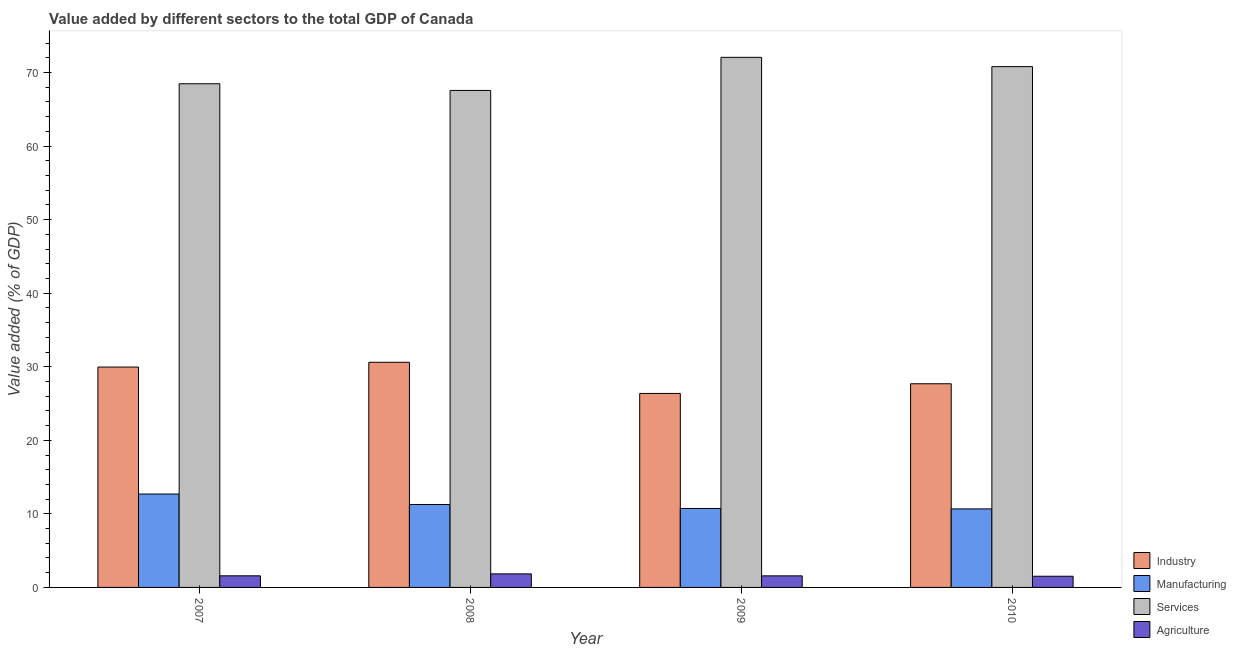How many different coloured bars are there?
Ensure brevity in your answer.  4. Are the number of bars per tick equal to the number of legend labels?
Provide a short and direct response. Yes. Are the number of bars on each tick of the X-axis equal?
Your answer should be compact. Yes. How many bars are there on the 1st tick from the left?
Provide a short and direct response. 4. How many bars are there on the 1st tick from the right?
Provide a short and direct response. 4. What is the value added by agricultural sector in 2010?
Your answer should be compact. 1.52. Across all years, what is the maximum value added by services sector?
Give a very brief answer. 72.06. Across all years, what is the minimum value added by industrial sector?
Offer a very short reply. 26.37. In which year was the value added by manufacturing sector minimum?
Keep it short and to the point. 2010. What is the total value added by services sector in the graph?
Keep it short and to the point. 278.87. What is the difference between the value added by services sector in 2008 and that in 2009?
Your answer should be very brief. -4.5. What is the difference between the value added by services sector in 2008 and the value added by agricultural sector in 2007?
Offer a very short reply. -0.91. What is the average value added by industrial sector per year?
Provide a short and direct response. 28.65. What is the ratio of the value added by manufacturing sector in 2007 to that in 2010?
Keep it short and to the point. 1.19. Is the difference between the value added by services sector in 2008 and 2010 greater than the difference between the value added by manufacturing sector in 2008 and 2010?
Keep it short and to the point. No. What is the difference between the highest and the second highest value added by services sector?
Ensure brevity in your answer.  1.26. What is the difference between the highest and the lowest value added by industrial sector?
Your answer should be very brief. 4.23. Is the sum of the value added by industrial sector in 2007 and 2009 greater than the maximum value added by agricultural sector across all years?
Provide a succinct answer. Yes. Is it the case that in every year, the sum of the value added by services sector and value added by industrial sector is greater than the sum of value added by agricultural sector and value added by manufacturing sector?
Keep it short and to the point. No. What does the 4th bar from the left in 2009 represents?
Offer a terse response. Agriculture. What does the 4th bar from the right in 2009 represents?
Your answer should be very brief. Industry. How many years are there in the graph?
Give a very brief answer. 4. What is the difference between two consecutive major ticks on the Y-axis?
Make the answer very short. 10. Are the values on the major ticks of Y-axis written in scientific E-notation?
Your answer should be compact. No. Does the graph contain any zero values?
Your response must be concise. No. Where does the legend appear in the graph?
Keep it short and to the point. Bottom right. How are the legend labels stacked?
Offer a terse response. Vertical. What is the title of the graph?
Provide a succinct answer. Value added by different sectors to the total GDP of Canada. What is the label or title of the X-axis?
Provide a short and direct response. Year. What is the label or title of the Y-axis?
Keep it short and to the point. Value added (% of GDP). What is the Value added (% of GDP) in Industry in 2007?
Your answer should be very brief. 29.95. What is the Value added (% of GDP) of Manufacturing in 2007?
Ensure brevity in your answer.  12.7. What is the Value added (% of GDP) in Services in 2007?
Provide a succinct answer. 68.47. What is the Value added (% of GDP) in Agriculture in 2007?
Your answer should be very brief. 1.58. What is the Value added (% of GDP) of Industry in 2008?
Keep it short and to the point. 30.6. What is the Value added (% of GDP) in Manufacturing in 2008?
Give a very brief answer. 11.27. What is the Value added (% of GDP) in Services in 2008?
Offer a terse response. 67.56. What is the Value added (% of GDP) of Agriculture in 2008?
Provide a succinct answer. 1.84. What is the Value added (% of GDP) in Industry in 2009?
Your answer should be compact. 26.37. What is the Value added (% of GDP) of Manufacturing in 2009?
Make the answer very short. 10.73. What is the Value added (% of GDP) in Services in 2009?
Your answer should be very brief. 72.06. What is the Value added (% of GDP) in Agriculture in 2009?
Your response must be concise. 1.57. What is the Value added (% of GDP) of Industry in 2010?
Provide a short and direct response. 27.69. What is the Value added (% of GDP) of Manufacturing in 2010?
Ensure brevity in your answer.  10.68. What is the Value added (% of GDP) of Services in 2010?
Ensure brevity in your answer.  70.79. What is the Value added (% of GDP) of Agriculture in 2010?
Make the answer very short. 1.52. Across all years, what is the maximum Value added (% of GDP) of Industry?
Provide a succinct answer. 30.6. Across all years, what is the maximum Value added (% of GDP) in Manufacturing?
Your answer should be very brief. 12.7. Across all years, what is the maximum Value added (% of GDP) of Services?
Your response must be concise. 72.06. Across all years, what is the maximum Value added (% of GDP) of Agriculture?
Provide a succinct answer. 1.84. Across all years, what is the minimum Value added (% of GDP) in Industry?
Your answer should be compact. 26.37. Across all years, what is the minimum Value added (% of GDP) of Manufacturing?
Give a very brief answer. 10.68. Across all years, what is the minimum Value added (% of GDP) in Services?
Keep it short and to the point. 67.56. Across all years, what is the minimum Value added (% of GDP) of Agriculture?
Offer a terse response. 1.52. What is the total Value added (% of GDP) of Industry in the graph?
Offer a terse response. 114.61. What is the total Value added (% of GDP) of Manufacturing in the graph?
Offer a very short reply. 45.38. What is the total Value added (% of GDP) of Services in the graph?
Provide a short and direct response. 278.87. What is the total Value added (% of GDP) in Agriculture in the graph?
Provide a short and direct response. 6.51. What is the difference between the Value added (% of GDP) of Industry in 2007 and that in 2008?
Offer a terse response. -0.65. What is the difference between the Value added (% of GDP) in Manufacturing in 2007 and that in 2008?
Ensure brevity in your answer.  1.42. What is the difference between the Value added (% of GDP) of Services in 2007 and that in 2008?
Offer a very short reply. 0.91. What is the difference between the Value added (% of GDP) of Agriculture in 2007 and that in 2008?
Provide a short and direct response. -0.26. What is the difference between the Value added (% of GDP) of Industry in 2007 and that in 2009?
Make the answer very short. 3.59. What is the difference between the Value added (% of GDP) in Manufacturing in 2007 and that in 2009?
Offer a terse response. 1.96. What is the difference between the Value added (% of GDP) of Services in 2007 and that in 2009?
Offer a terse response. -3.59. What is the difference between the Value added (% of GDP) of Agriculture in 2007 and that in 2009?
Offer a terse response. 0.01. What is the difference between the Value added (% of GDP) in Industry in 2007 and that in 2010?
Your answer should be very brief. 2.27. What is the difference between the Value added (% of GDP) in Manufacturing in 2007 and that in 2010?
Give a very brief answer. 2.02. What is the difference between the Value added (% of GDP) in Services in 2007 and that in 2010?
Give a very brief answer. -2.33. What is the difference between the Value added (% of GDP) in Agriculture in 2007 and that in 2010?
Offer a terse response. 0.06. What is the difference between the Value added (% of GDP) in Industry in 2008 and that in 2009?
Give a very brief answer. 4.23. What is the difference between the Value added (% of GDP) in Manufacturing in 2008 and that in 2009?
Provide a succinct answer. 0.54. What is the difference between the Value added (% of GDP) in Services in 2008 and that in 2009?
Provide a short and direct response. -4.5. What is the difference between the Value added (% of GDP) in Agriculture in 2008 and that in 2009?
Give a very brief answer. 0.27. What is the difference between the Value added (% of GDP) in Industry in 2008 and that in 2010?
Your answer should be very brief. 2.92. What is the difference between the Value added (% of GDP) in Manufacturing in 2008 and that in 2010?
Your response must be concise. 0.6. What is the difference between the Value added (% of GDP) in Services in 2008 and that in 2010?
Your answer should be compact. -3.24. What is the difference between the Value added (% of GDP) of Agriculture in 2008 and that in 2010?
Give a very brief answer. 0.32. What is the difference between the Value added (% of GDP) in Industry in 2009 and that in 2010?
Offer a very short reply. -1.32. What is the difference between the Value added (% of GDP) in Manufacturing in 2009 and that in 2010?
Keep it short and to the point. 0.06. What is the difference between the Value added (% of GDP) of Services in 2009 and that in 2010?
Your answer should be compact. 1.26. What is the difference between the Value added (% of GDP) in Agriculture in 2009 and that in 2010?
Offer a very short reply. 0.05. What is the difference between the Value added (% of GDP) in Industry in 2007 and the Value added (% of GDP) in Manufacturing in 2008?
Make the answer very short. 18.68. What is the difference between the Value added (% of GDP) of Industry in 2007 and the Value added (% of GDP) of Services in 2008?
Provide a succinct answer. -37.6. What is the difference between the Value added (% of GDP) of Industry in 2007 and the Value added (% of GDP) of Agriculture in 2008?
Give a very brief answer. 28.11. What is the difference between the Value added (% of GDP) in Manufacturing in 2007 and the Value added (% of GDP) in Services in 2008?
Give a very brief answer. -54.86. What is the difference between the Value added (% of GDP) in Manufacturing in 2007 and the Value added (% of GDP) in Agriculture in 2008?
Give a very brief answer. 10.85. What is the difference between the Value added (% of GDP) of Services in 2007 and the Value added (% of GDP) of Agriculture in 2008?
Your answer should be compact. 66.63. What is the difference between the Value added (% of GDP) of Industry in 2007 and the Value added (% of GDP) of Manufacturing in 2009?
Your answer should be very brief. 19.22. What is the difference between the Value added (% of GDP) of Industry in 2007 and the Value added (% of GDP) of Services in 2009?
Your answer should be very brief. -42.1. What is the difference between the Value added (% of GDP) of Industry in 2007 and the Value added (% of GDP) of Agriculture in 2009?
Ensure brevity in your answer.  28.38. What is the difference between the Value added (% of GDP) of Manufacturing in 2007 and the Value added (% of GDP) of Services in 2009?
Your answer should be very brief. -59.36. What is the difference between the Value added (% of GDP) in Manufacturing in 2007 and the Value added (% of GDP) in Agriculture in 2009?
Your response must be concise. 11.12. What is the difference between the Value added (% of GDP) of Services in 2007 and the Value added (% of GDP) of Agriculture in 2009?
Your response must be concise. 66.89. What is the difference between the Value added (% of GDP) of Industry in 2007 and the Value added (% of GDP) of Manufacturing in 2010?
Your answer should be compact. 19.28. What is the difference between the Value added (% of GDP) in Industry in 2007 and the Value added (% of GDP) in Services in 2010?
Provide a short and direct response. -40.84. What is the difference between the Value added (% of GDP) in Industry in 2007 and the Value added (% of GDP) in Agriculture in 2010?
Your answer should be very brief. 28.43. What is the difference between the Value added (% of GDP) in Manufacturing in 2007 and the Value added (% of GDP) in Services in 2010?
Provide a short and direct response. -58.1. What is the difference between the Value added (% of GDP) in Manufacturing in 2007 and the Value added (% of GDP) in Agriculture in 2010?
Offer a terse response. 11.18. What is the difference between the Value added (% of GDP) of Services in 2007 and the Value added (% of GDP) of Agriculture in 2010?
Ensure brevity in your answer.  66.95. What is the difference between the Value added (% of GDP) of Industry in 2008 and the Value added (% of GDP) of Manufacturing in 2009?
Ensure brevity in your answer.  19.87. What is the difference between the Value added (% of GDP) in Industry in 2008 and the Value added (% of GDP) in Services in 2009?
Keep it short and to the point. -41.45. What is the difference between the Value added (% of GDP) of Industry in 2008 and the Value added (% of GDP) of Agriculture in 2009?
Keep it short and to the point. 29.03. What is the difference between the Value added (% of GDP) in Manufacturing in 2008 and the Value added (% of GDP) in Services in 2009?
Keep it short and to the point. -60.78. What is the difference between the Value added (% of GDP) of Manufacturing in 2008 and the Value added (% of GDP) of Agriculture in 2009?
Your answer should be compact. 9.7. What is the difference between the Value added (% of GDP) of Services in 2008 and the Value added (% of GDP) of Agriculture in 2009?
Provide a short and direct response. 65.98. What is the difference between the Value added (% of GDP) in Industry in 2008 and the Value added (% of GDP) in Manufacturing in 2010?
Ensure brevity in your answer.  19.93. What is the difference between the Value added (% of GDP) of Industry in 2008 and the Value added (% of GDP) of Services in 2010?
Give a very brief answer. -40.19. What is the difference between the Value added (% of GDP) of Industry in 2008 and the Value added (% of GDP) of Agriculture in 2010?
Ensure brevity in your answer.  29.08. What is the difference between the Value added (% of GDP) in Manufacturing in 2008 and the Value added (% of GDP) in Services in 2010?
Offer a terse response. -59.52. What is the difference between the Value added (% of GDP) of Manufacturing in 2008 and the Value added (% of GDP) of Agriculture in 2010?
Give a very brief answer. 9.75. What is the difference between the Value added (% of GDP) of Services in 2008 and the Value added (% of GDP) of Agriculture in 2010?
Provide a succinct answer. 66.03. What is the difference between the Value added (% of GDP) in Industry in 2009 and the Value added (% of GDP) in Manufacturing in 2010?
Provide a short and direct response. 15.69. What is the difference between the Value added (% of GDP) in Industry in 2009 and the Value added (% of GDP) in Services in 2010?
Give a very brief answer. -44.42. What is the difference between the Value added (% of GDP) in Industry in 2009 and the Value added (% of GDP) in Agriculture in 2010?
Keep it short and to the point. 24.85. What is the difference between the Value added (% of GDP) in Manufacturing in 2009 and the Value added (% of GDP) in Services in 2010?
Provide a succinct answer. -60.06. What is the difference between the Value added (% of GDP) of Manufacturing in 2009 and the Value added (% of GDP) of Agriculture in 2010?
Offer a terse response. 9.21. What is the difference between the Value added (% of GDP) of Services in 2009 and the Value added (% of GDP) of Agriculture in 2010?
Provide a short and direct response. 70.54. What is the average Value added (% of GDP) in Industry per year?
Offer a very short reply. 28.65. What is the average Value added (% of GDP) of Manufacturing per year?
Provide a succinct answer. 11.34. What is the average Value added (% of GDP) of Services per year?
Provide a succinct answer. 69.72. What is the average Value added (% of GDP) of Agriculture per year?
Give a very brief answer. 1.63. In the year 2007, what is the difference between the Value added (% of GDP) in Industry and Value added (% of GDP) in Manufacturing?
Keep it short and to the point. 17.26. In the year 2007, what is the difference between the Value added (% of GDP) in Industry and Value added (% of GDP) in Services?
Offer a very short reply. -38.51. In the year 2007, what is the difference between the Value added (% of GDP) in Industry and Value added (% of GDP) in Agriculture?
Provide a succinct answer. 28.38. In the year 2007, what is the difference between the Value added (% of GDP) in Manufacturing and Value added (% of GDP) in Services?
Offer a terse response. -55.77. In the year 2007, what is the difference between the Value added (% of GDP) in Manufacturing and Value added (% of GDP) in Agriculture?
Your answer should be compact. 11.12. In the year 2007, what is the difference between the Value added (% of GDP) of Services and Value added (% of GDP) of Agriculture?
Your response must be concise. 66.89. In the year 2008, what is the difference between the Value added (% of GDP) of Industry and Value added (% of GDP) of Manufacturing?
Your answer should be very brief. 19.33. In the year 2008, what is the difference between the Value added (% of GDP) of Industry and Value added (% of GDP) of Services?
Give a very brief answer. -36.95. In the year 2008, what is the difference between the Value added (% of GDP) in Industry and Value added (% of GDP) in Agriculture?
Provide a succinct answer. 28.76. In the year 2008, what is the difference between the Value added (% of GDP) in Manufacturing and Value added (% of GDP) in Services?
Make the answer very short. -56.28. In the year 2008, what is the difference between the Value added (% of GDP) in Manufacturing and Value added (% of GDP) in Agriculture?
Keep it short and to the point. 9.43. In the year 2008, what is the difference between the Value added (% of GDP) in Services and Value added (% of GDP) in Agriculture?
Ensure brevity in your answer.  65.71. In the year 2009, what is the difference between the Value added (% of GDP) of Industry and Value added (% of GDP) of Manufacturing?
Your answer should be compact. 15.64. In the year 2009, what is the difference between the Value added (% of GDP) of Industry and Value added (% of GDP) of Services?
Your response must be concise. -45.69. In the year 2009, what is the difference between the Value added (% of GDP) of Industry and Value added (% of GDP) of Agriculture?
Your response must be concise. 24.8. In the year 2009, what is the difference between the Value added (% of GDP) in Manufacturing and Value added (% of GDP) in Services?
Provide a succinct answer. -61.32. In the year 2009, what is the difference between the Value added (% of GDP) in Manufacturing and Value added (% of GDP) in Agriculture?
Offer a terse response. 9.16. In the year 2009, what is the difference between the Value added (% of GDP) of Services and Value added (% of GDP) of Agriculture?
Offer a very short reply. 70.48. In the year 2010, what is the difference between the Value added (% of GDP) of Industry and Value added (% of GDP) of Manufacturing?
Keep it short and to the point. 17.01. In the year 2010, what is the difference between the Value added (% of GDP) of Industry and Value added (% of GDP) of Services?
Your answer should be compact. -43.11. In the year 2010, what is the difference between the Value added (% of GDP) in Industry and Value added (% of GDP) in Agriculture?
Give a very brief answer. 26.16. In the year 2010, what is the difference between the Value added (% of GDP) of Manufacturing and Value added (% of GDP) of Services?
Keep it short and to the point. -60.12. In the year 2010, what is the difference between the Value added (% of GDP) of Manufacturing and Value added (% of GDP) of Agriculture?
Offer a terse response. 9.15. In the year 2010, what is the difference between the Value added (% of GDP) of Services and Value added (% of GDP) of Agriculture?
Provide a short and direct response. 69.27. What is the ratio of the Value added (% of GDP) in Industry in 2007 to that in 2008?
Your response must be concise. 0.98. What is the ratio of the Value added (% of GDP) in Manufacturing in 2007 to that in 2008?
Ensure brevity in your answer.  1.13. What is the ratio of the Value added (% of GDP) in Services in 2007 to that in 2008?
Offer a very short reply. 1.01. What is the ratio of the Value added (% of GDP) in Agriculture in 2007 to that in 2008?
Give a very brief answer. 0.86. What is the ratio of the Value added (% of GDP) of Industry in 2007 to that in 2009?
Give a very brief answer. 1.14. What is the ratio of the Value added (% of GDP) in Manufacturing in 2007 to that in 2009?
Ensure brevity in your answer.  1.18. What is the ratio of the Value added (% of GDP) in Services in 2007 to that in 2009?
Provide a short and direct response. 0.95. What is the ratio of the Value added (% of GDP) in Agriculture in 2007 to that in 2009?
Provide a succinct answer. 1. What is the ratio of the Value added (% of GDP) of Industry in 2007 to that in 2010?
Keep it short and to the point. 1.08. What is the ratio of the Value added (% of GDP) in Manufacturing in 2007 to that in 2010?
Your answer should be compact. 1.19. What is the ratio of the Value added (% of GDP) of Services in 2007 to that in 2010?
Ensure brevity in your answer.  0.97. What is the ratio of the Value added (% of GDP) in Agriculture in 2007 to that in 2010?
Your answer should be compact. 1.04. What is the ratio of the Value added (% of GDP) in Industry in 2008 to that in 2009?
Provide a short and direct response. 1.16. What is the ratio of the Value added (% of GDP) of Manufacturing in 2008 to that in 2009?
Provide a short and direct response. 1.05. What is the ratio of the Value added (% of GDP) of Services in 2008 to that in 2009?
Your answer should be very brief. 0.94. What is the ratio of the Value added (% of GDP) of Agriculture in 2008 to that in 2009?
Keep it short and to the point. 1.17. What is the ratio of the Value added (% of GDP) of Industry in 2008 to that in 2010?
Ensure brevity in your answer.  1.11. What is the ratio of the Value added (% of GDP) in Manufacturing in 2008 to that in 2010?
Give a very brief answer. 1.06. What is the ratio of the Value added (% of GDP) of Services in 2008 to that in 2010?
Give a very brief answer. 0.95. What is the ratio of the Value added (% of GDP) in Agriculture in 2008 to that in 2010?
Your answer should be very brief. 1.21. What is the ratio of the Value added (% of GDP) in Industry in 2009 to that in 2010?
Offer a very short reply. 0.95. What is the ratio of the Value added (% of GDP) in Manufacturing in 2009 to that in 2010?
Your response must be concise. 1.01. What is the ratio of the Value added (% of GDP) of Services in 2009 to that in 2010?
Provide a short and direct response. 1.02. What is the ratio of the Value added (% of GDP) of Agriculture in 2009 to that in 2010?
Offer a very short reply. 1.03. What is the difference between the highest and the second highest Value added (% of GDP) of Industry?
Provide a succinct answer. 0.65. What is the difference between the highest and the second highest Value added (% of GDP) of Manufacturing?
Provide a succinct answer. 1.42. What is the difference between the highest and the second highest Value added (% of GDP) in Services?
Offer a very short reply. 1.26. What is the difference between the highest and the second highest Value added (% of GDP) of Agriculture?
Your answer should be compact. 0.26. What is the difference between the highest and the lowest Value added (% of GDP) in Industry?
Your response must be concise. 4.23. What is the difference between the highest and the lowest Value added (% of GDP) of Manufacturing?
Offer a very short reply. 2.02. What is the difference between the highest and the lowest Value added (% of GDP) of Services?
Offer a very short reply. 4.5. What is the difference between the highest and the lowest Value added (% of GDP) of Agriculture?
Offer a very short reply. 0.32. 